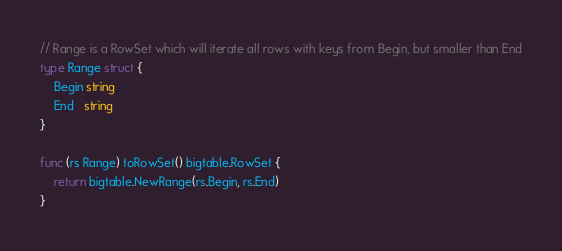<code> <loc_0><loc_0><loc_500><loc_500><_Go_>// Range is a RowSet which will iterate all rows with keys from Begin, but smaller than End
type Range struct {
	Begin string
	End   string
}

func (rs Range) toRowSet() bigtable.RowSet {
	return bigtable.NewRange(rs.Begin, rs.End)
}
</code> 